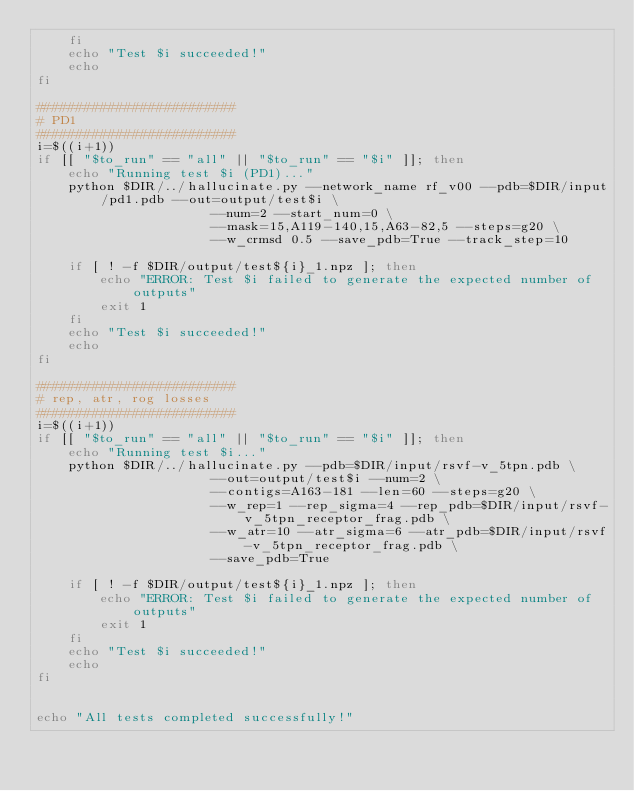Convert code to text. <code><loc_0><loc_0><loc_500><loc_500><_Bash_>    fi
    echo "Test $i succeeded!"
    echo
fi

#########################
# PD1
#########################
i=$((i+1))
if [[ "$to_run" == "all" || "$to_run" == "$i" ]]; then
    echo "Running test $i (PD1)..."
    python $DIR/../hallucinate.py --network_name rf_v00 --pdb=$DIR/input/pd1.pdb --out=output/test$i \
                      --num=2 --start_num=0 \
                      --mask=15,A119-140,15,A63-82,5 --steps=g20 \
                      --w_crmsd 0.5 --save_pdb=True --track_step=10

    if [ ! -f $DIR/output/test${i}_1.npz ]; then
        echo "ERROR: Test $i failed to generate the expected number of outputs"
        exit 1
    fi
    echo "Test $i succeeded!"
    echo
fi

#########################
# rep, atr, rog losses
#########################
i=$((i+1))
if [[ "$to_run" == "all" || "$to_run" == "$i" ]]; then
    echo "Running test $i..."
    python $DIR/../hallucinate.py --pdb=$DIR/input/rsvf-v_5tpn.pdb \
                      --out=output/test$i --num=2 \
                      --contigs=A163-181 --len=60 --steps=g20 \
                      --w_rep=1 --rep_sigma=4 --rep_pdb=$DIR/input/rsvf-v_5tpn_receptor_frag.pdb \
                      --w_atr=10 --atr_sigma=6 --atr_pdb=$DIR/input/rsvf-v_5tpn_receptor_frag.pdb \
                      --save_pdb=True 

    if [ ! -f $DIR/output/test${i}_1.npz ]; then
        echo "ERROR: Test $i failed to generate the expected number of outputs"
        exit 1
    fi
    echo "Test $i succeeded!"
    echo
fi


echo "All tests completed successfully!"
</code> 